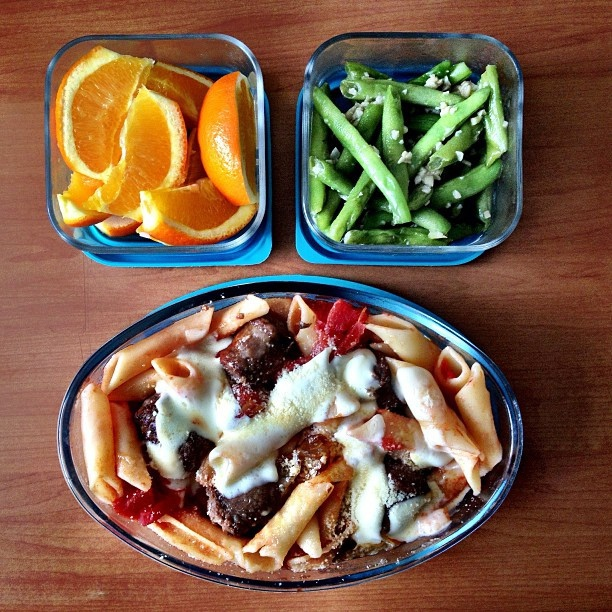Describe the objects in this image and their specific colors. I can see dining table in maroon, black, brown, and ivory tones, bowl in maroon, black, darkgreen, gray, and lightgreen tones, bowl in maroon, orange, and brown tones, orange in maroon, orange, khaki, and red tones, and orange in maroon, orange, and red tones in this image. 